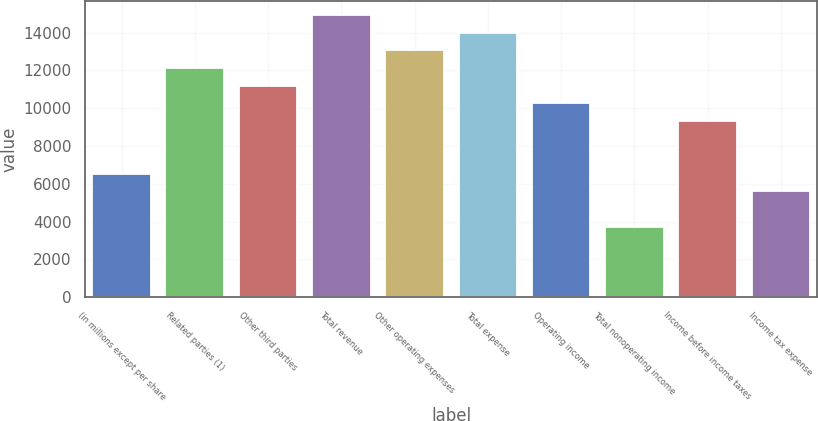Convert chart to OTSL. <chart><loc_0><loc_0><loc_500><loc_500><bar_chart><fcel>(in millions except per share<fcel>Related parties (1)<fcel>Other third parties<fcel>Total revenue<fcel>Other operating expenses<fcel>Total expense<fcel>Operating income<fcel>Total nonoperating income<fcel>Income before income taxes<fcel>Income tax expense<nl><fcel>6537.7<fcel>12136.3<fcel>11203.2<fcel>14935.6<fcel>13069.4<fcel>14002.5<fcel>10270.1<fcel>3738.4<fcel>9337<fcel>5604.6<nl></chart> 